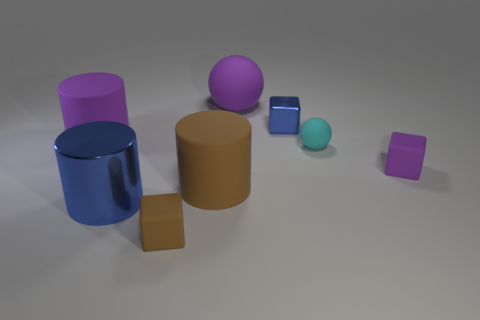There is another small block that is made of the same material as the small purple block; what is its color?
Keep it short and to the point. Brown. Is the color of the metallic cylinder the same as the ball to the right of the blue metallic cube?
Offer a very short reply. No. There is a matte ball that is in front of the large purple object that is on the left side of the big blue object; are there any purple cubes on the left side of it?
Your answer should be compact. No. There is a big purple object that is the same material as the big purple sphere; what shape is it?
Make the answer very short. Cylinder. What is the shape of the small blue shiny thing?
Provide a succinct answer. Cube. There is a blue metallic object behind the large brown cylinder; is it the same shape as the small purple object?
Your answer should be very brief. Yes. Is the number of large metal things that are to the left of the large brown thing greater than the number of blue cubes that are left of the small brown rubber object?
Make the answer very short. Yes. How many other things are the same size as the blue cylinder?
Provide a succinct answer. 3. Is the shape of the cyan matte object the same as the tiny thing that is to the left of the big brown cylinder?
Give a very brief answer. No. How many shiny things are purple cylinders or brown things?
Ensure brevity in your answer.  0. 